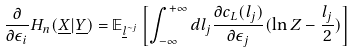Convert formula to latex. <formula><loc_0><loc_0><loc_500><loc_500>\frac { \partial } { \partial \epsilon _ { i } } H _ { n } ( \underline { X } | \underline { Y } ) & = \mathbb { E } _ { \underline { l } ^ { \sim j } } \left [ \int _ { - \infty } ^ { + \infty } d l _ { j } \frac { \partial c _ { L } ( l _ { j } ) } { \partial \epsilon _ { j } } ( \ln Z - \frac { l _ { j } } { 2 } ) \right ]</formula> 